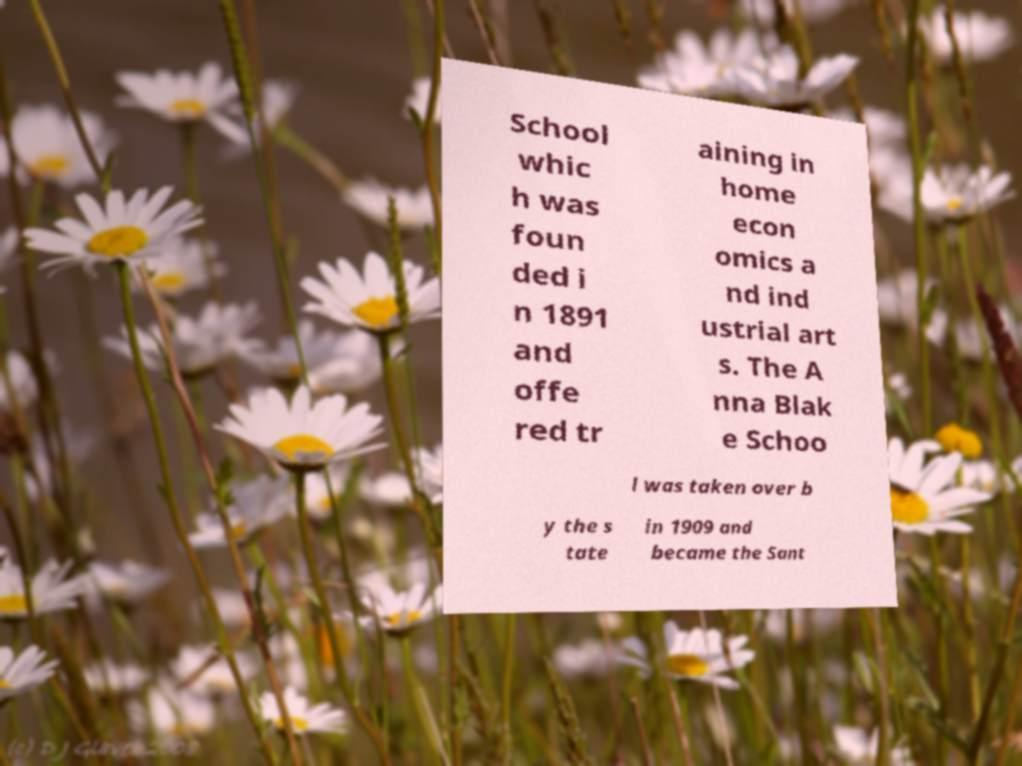Could you extract and type out the text from this image? School whic h was foun ded i n 1891 and offe red tr aining in home econ omics a nd ind ustrial art s. The A nna Blak e Schoo l was taken over b y the s tate in 1909 and became the Sant 